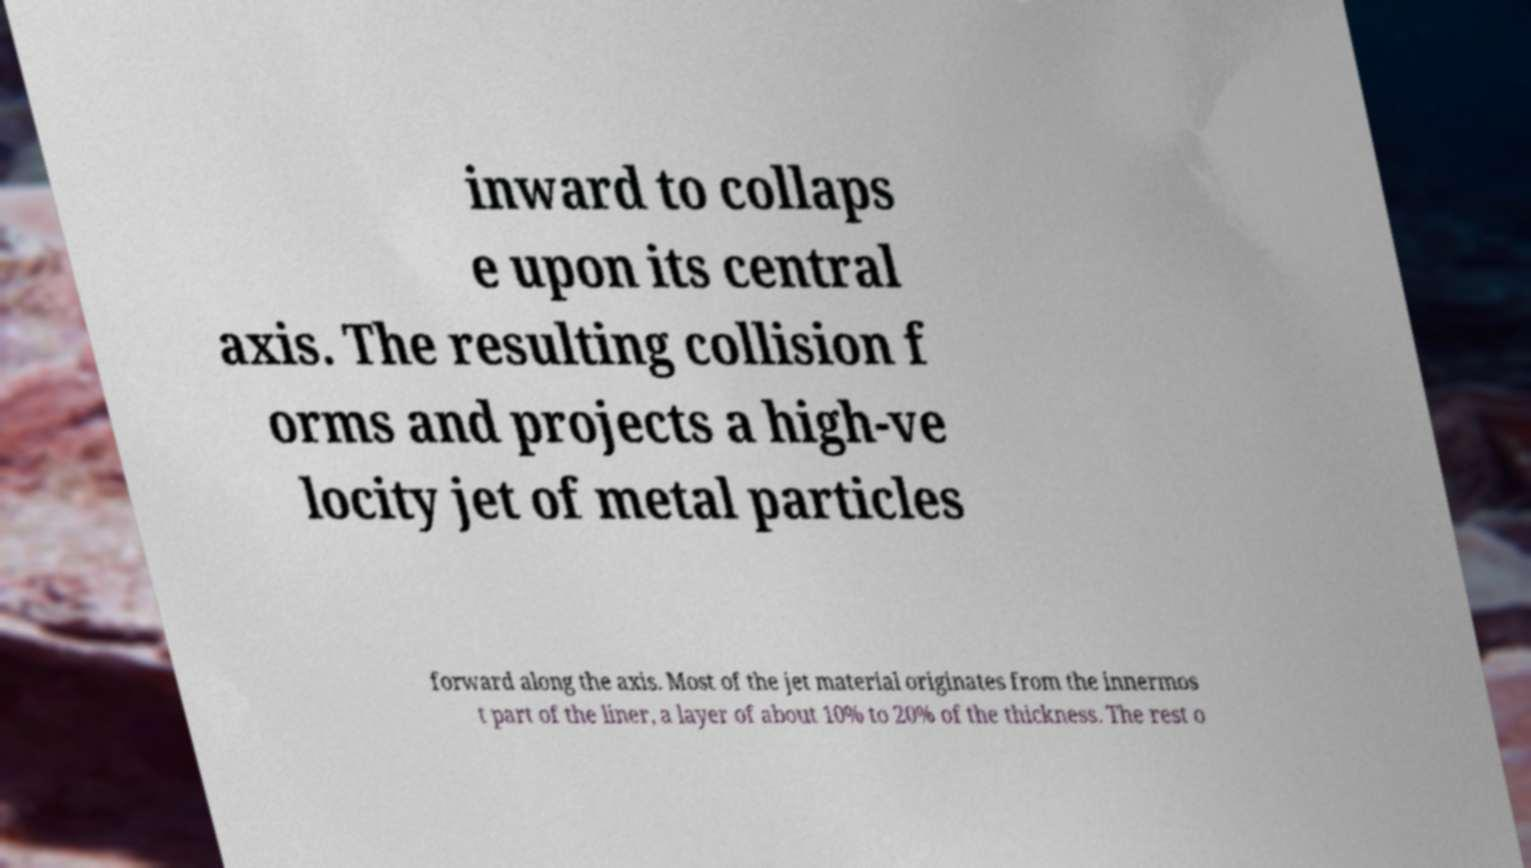Please identify and transcribe the text found in this image. inward to collaps e upon its central axis. The resulting collision f orms and projects a high-ve locity jet of metal particles forward along the axis. Most of the jet material originates from the innermos t part of the liner, a layer of about 10% to 20% of the thickness. The rest o 